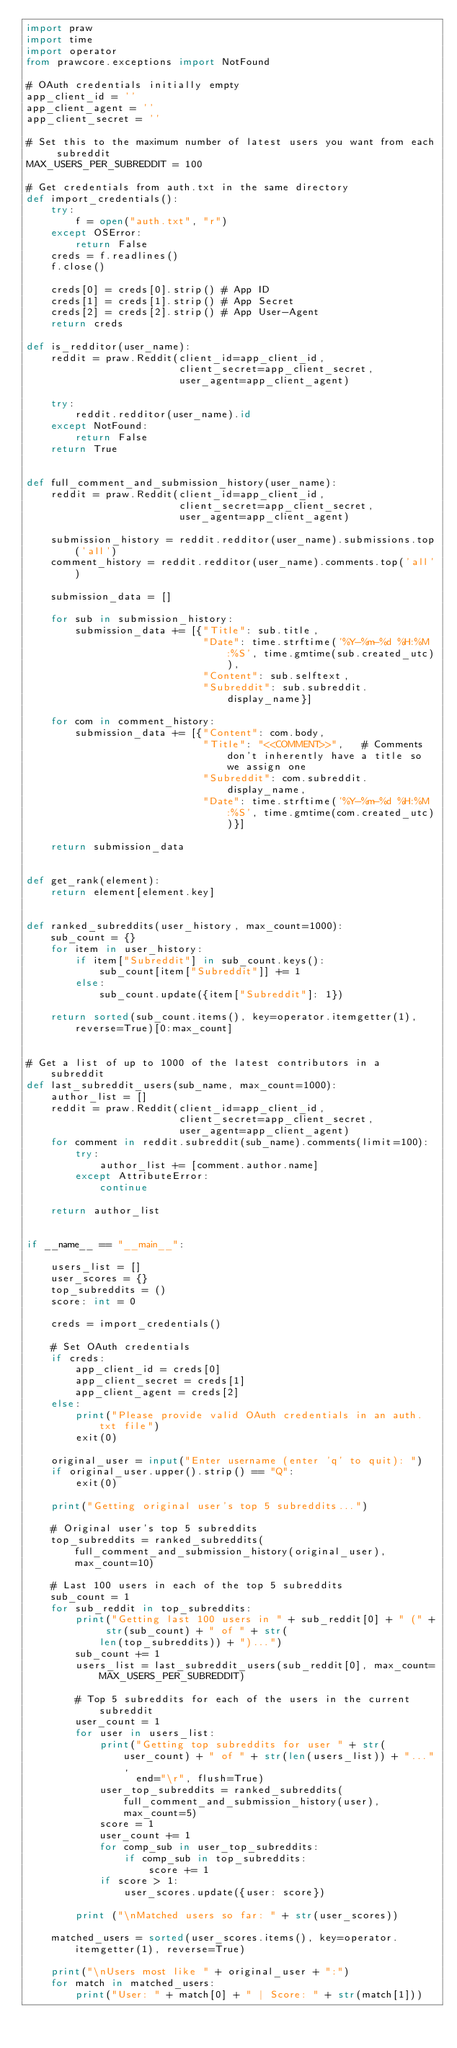Convert code to text. <code><loc_0><loc_0><loc_500><loc_500><_Python_>import praw
import time
import operator
from prawcore.exceptions import NotFound

# OAuth credentials initially empty
app_client_id = ''
app_client_agent = ''
app_client_secret = ''

# Set this to the maximum number of latest users you want from each subreddit
MAX_USERS_PER_SUBREDDIT = 100

# Get credentials from auth.txt in the same directory
def import_credentials():
    try:
        f = open("auth.txt", "r")
    except OSError:
        return False
    creds = f.readlines()
    f.close()

    creds[0] = creds[0].strip() # App ID
    creds[1] = creds[1].strip() # App Secret
    creds[2] = creds[2].strip() # App User-Agent
    return creds

def is_redditor(user_name):
    reddit = praw.Reddit(client_id=app_client_id,
                         client_secret=app_client_secret,
                         user_agent=app_client_agent)

    try:
        reddit.redditor(user_name).id
    except NotFound:
        return False
    return True


def full_comment_and_submission_history(user_name):
    reddit = praw.Reddit(client_id=app_client_id,
                         client_secret=app_client_secret,
                         user_agent=app_client_agent)

    submission_history = reddit.redditor(user_name).submissions.top('all')
    comment_history = reddit.redditor(user_name).comments.top('all')

    submission_data = []

    for sub in submission_history:
        submission_data += [{"Title": sub.title,
                             "Date": time.strftime('%Y-%m-%d %H:%M:%S', time.gmtime(sub.created_utc)),
                             "Content": sub.selftext,
                             "Subreddit": sub.subreddit.display_name}]

    for com in comment_history:
        submission_data += [{"Content": com.body,
                             "Title": "<<COMMENT>>",   # Comments don't inherently have a title so we assign one
                             "Subreddit": com.subreddit.display_name,
                             "Date": time.strftime('%Y-%m-%d %H:%M:%S', time.gmtime(com.created_utc))}]

    return submission_data


def get_rank(element):
    return element[element.key]


def ranked_subreddits(user_history, max_count=1000):
    sub_count = {}
    for item in user_history:
        if item["Subreddit"] in sub_count.keys():
            sub_count[item["Subreddit"]] += 1
        else:
            sub_count.update({item["Subreddit"]: 1})

    return sorted(sub_count.items(), key=operator.itemgetter(1), reverse=True)[0:max_count]


# Get a list of up to 1000 of the latest contributors in a subreddit
def last_subreddit_users(sub_name, max_count=1000):
    author_list = []
    reddit = praw.Reddit(client_id=app_client_id,
                         client_secret=app_client_secret,
                         user_agent=app_client_agent)
    for comment in reddit.subreddit(sub_name).comments(limit=100):
        try:
            author_list += [comment.author.name]
        except AttributeError:
            continue

    return author_list


if __name__ == "__main__":

    users_list = []
    user_scores = {}
    top_subreddits = ()
    score: int = 0

    creds = import_credentials()

    # Set OAuth credentials
    if creds:
        app_client_id = creds[0]
        app_client_secret = creds[1]
        app_client_agent = creds[2]
    else:
        print("Please provide valid OAuth credentials in an auth.txt file")
        exit(0)

    original_user = input("Enter username (enter 'q' to quit): ")
    if original_user.upper().strip() == "Q":
        exit(0)

    print("Getting original user's top 5 subreddits...")

    # Original user's top 5 subreddits
    top_subreddits = ranked_subreddits(full_comment_and_submission_history(original_user), max_count=10)

    # Last 100 users in each of the top 5 subreddits
    sub_count = 1
    for sub_reddit in top_subreddits:
        print("Getting last 100 users in " + sub_reddit[0] + " (" + str(sub_count) + " of " + str(
            len(top_subreddits)) + ")...")
        sub_count += 1
        users_list = last_subreddit_users(sub_reddit[0], max_count=MAX_USERS_PER_SUBREDDIT)

        # Top 5 subreddits for each of the users in the current subreddit
        user_count = 1
        for user in users_list:
            print("Getting top subreddits for user " + str(user_count) + " of " + str(len(users_list)) + "...",
                  end="\r", flush=True)
            user_top_subreddits = ranked_subreddits(full_comment_and_submission_history(user), max_count=5)
            score = 1
            user_count += 1
            for comp_sub in user_top_subreddits:
                if comp_sub in top_subreddits:
                    score += 1
            if score > 1:
                user_scores.update({user: score})

        print ("\nMatched users so far: " + str(user_scores))

    matched_users = sorted(user_scores.items(), key=operator.itemgetter(1), reverse=True)

    print("\nUsers most like " + original_user + ":")
    for match in matched_users:
        print("User: " + match[0] + " | Score: " + str(match[1]))
</code> 